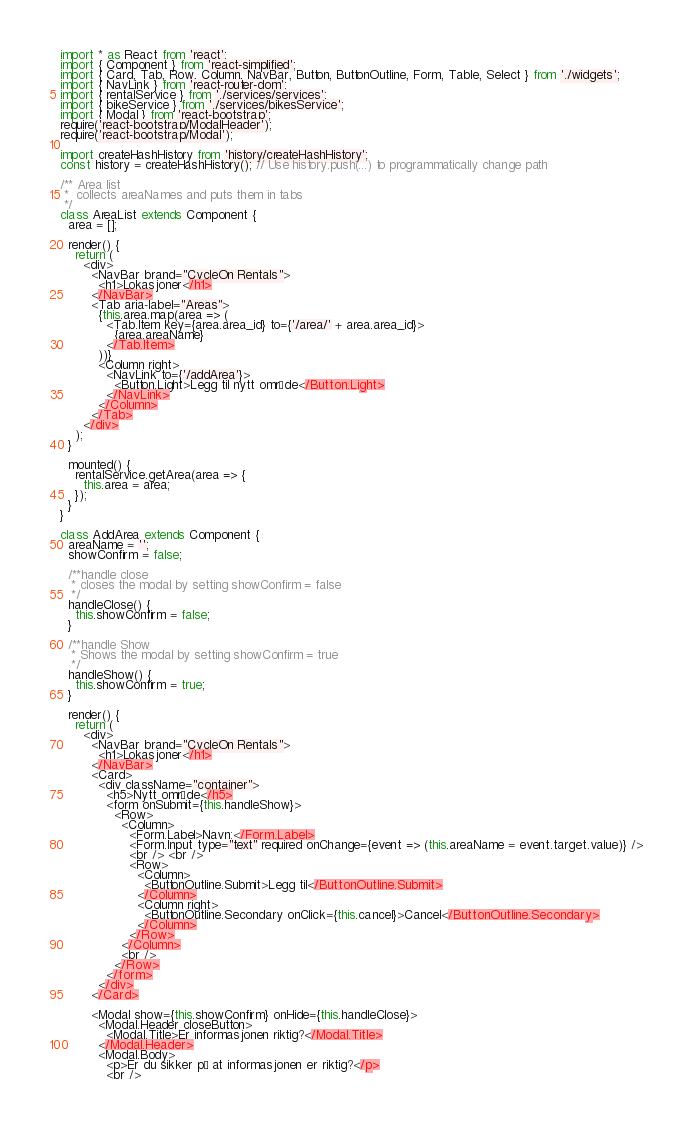Convert code to text. <code><loc_0><loc_0><loc_500><loc_500><_JavaScript_>import * as React from 'react';
import { Component } from 'react-simplified';
import { Card, Tab, Row, Column, NavBar, Button, ButtonOutline, Form, Table, Select } from './widgets';
import { NavLink } from 'react-router-dom';
import { rentalService } from './services/services';
import { bikeService } from './services/bikesService';
import { Modal } from 'react-bootstrap';
require('react-bootstrap/ModalHeader');
require('react-bootstrap/Modal');

import createHashHistory from 'history/createHashHistory';
const history = createHashHistory(); // Use history.push(...) to programmatically change path

/** Area list
 *  collects areaNames and puts them in tabs
 */
class AreaList extends Component {
  area = [];

  render() {
    return (
      <div>
        <NavBar brand="CycleOn Rentals">
          <h1>Lokasjoner</h1>
        </NavBar>
        <Tab aria-label="Areas">
          {this.area.map(area => (
            <Tab.Item key={area.area_id} to={'/area/' + area.area_id}>
              {area.areaName}
            </Tab.Item>
          ))}
          <Column right>
            <NavLink to={'/addArea'}>
              <Button.Light>Legg til nytt område</Button.Light>
            </NavLink>
          </Column>
        </Tab>
      </div>
    );
  }

  mounted() {
    rentalService.getArea(area => {
      this.area = area;
    });
  }
}

class AddArea extends Component {
  areaName = '';
  showConfirm = false;

  /**handle close
   * closes the modal by setting showConfirm = false
   */
  handleClose() {
    this.showConfirm = false;
  }

  /**handle Show
   * Shows the modal by setting showConfirm = true
   */
  handleShow() {
    this.showConfirm = true;
  }

  render() {
    return (
      <div>
        <NavBar brand="CycleOn Rentals">
          <h1>Lokasjoner</h1>
        </NavBar>
        <Card>
          <div className="container">
            <h5>Nytt område</h5>
            <form onSubmit={this.handleShow}>
              <Row>
                <Column>
                  <Form.Label>Navn:</Form.Label>
                  <Form.Input type="text" required onChange={event => (this.areaName = event.target.value)} />
                  <br /> <br />
                  <Row>
                    <Column>
                      <ButtonOutline.Submit>Legg til</ButtonOutline.Submit>
                    </Column>
                    <Column right>
                      <ButtonOutline.Secondary onClick={this.cancel}>Cancel</ButtonOutline.Secondary>
                    </Column>
                  </Row>
                </Column>
                <br />
              </Row>
            </form>
          </div>
        </Card>

        <Modal show={this.showConfirm} onHide={this.handleClose}>
          <Modal.Header closeButton>
            <Modal.Title>Er informasjonen riktig?</Modal.Title>
          </Modal.Header>
          <Modal.Body>
            <p>Er du sikker på at informasjonen er riktig?</p>
            <br /></code> 